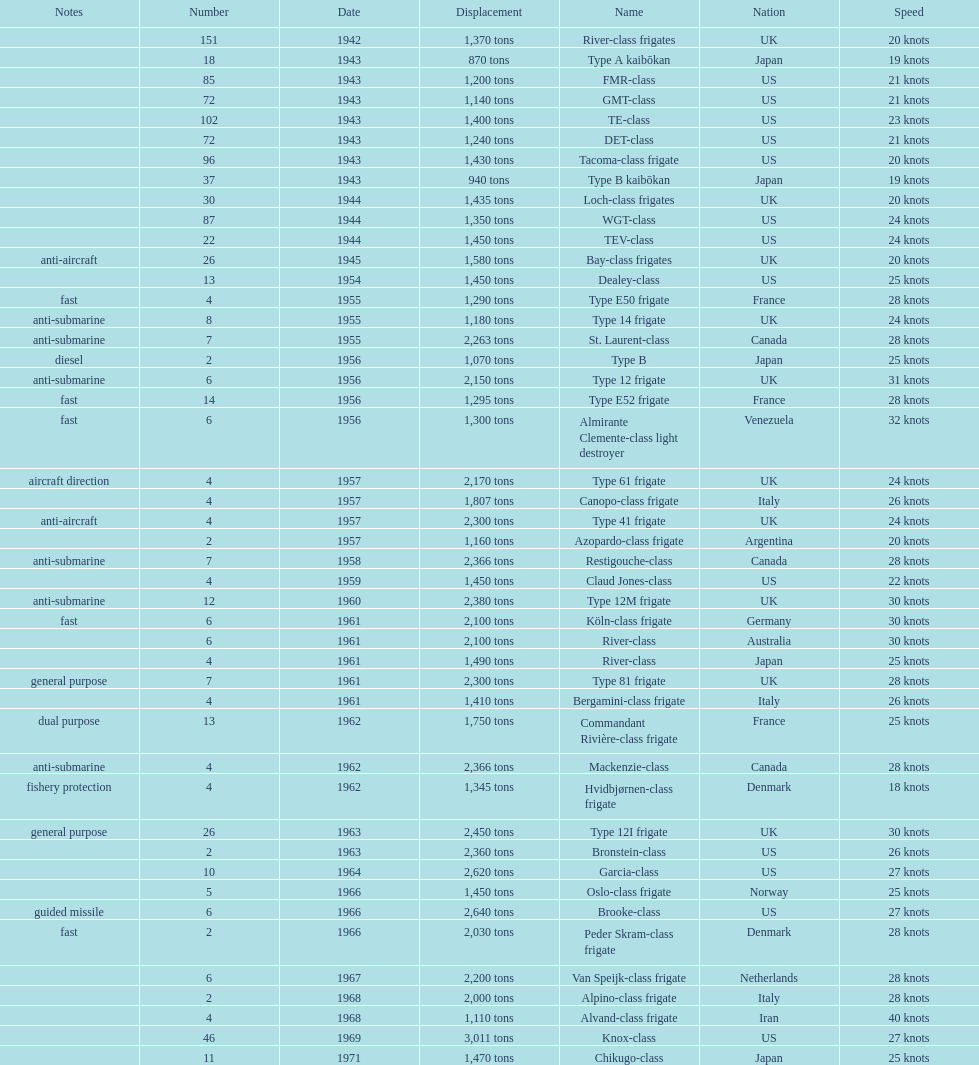Which name has the largest displacement? Knox-class. 